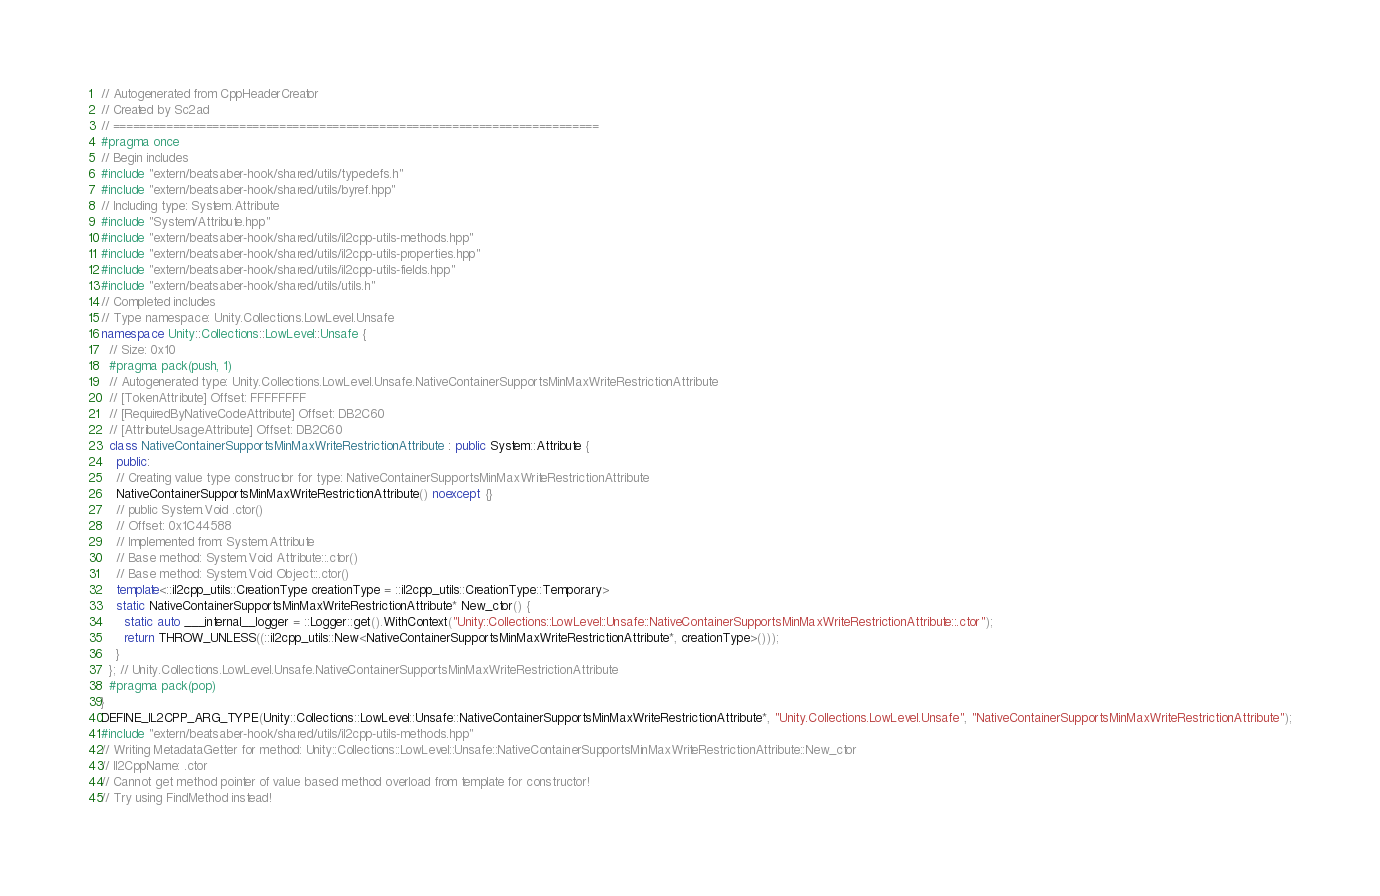Convert code to text. <code><loc_0><loc_0><loc_500><loc_500><_C++_>// Autogenerated from CppHeaderCreator
// Created by Sc2ad
// =========================================================================
#pragma once
// Begin includes
#include "extern/beatsaber-hook/shared/utils/typedefs.h"
#include "extern/beatsaber-hook/shared/utils/byref.hpp"
// Including type: System.Attribute
#include "System/Attribute.hpp"
#include "extern/beatsaber-hook/shared/utils/il2cpp-utils-methods.hpp"
#include "extern/beatsaber-hook/shared/utils/il2cpp-utils-properties.hpp"
#include "extern/beatsaber-hook/shared/utils/il2cpp-utils-fields.hpp"
#include "extern/beatsaber-hook/shared/utils/utils.h"
// Completed includes
// Type namespace: Unity.Collections.LowLevel.Unsafe
namespace Unity::Collections::LowLevel::Unsafe {
  // Size: 0x10
  #pragma pack(push, 1)
  // Autogenerated type: Unity.Collections.LowLevel.Unsafe.NativeContainerSupportsMinMaxWriteRestrictionAttribute
  // [TokenAttribute] Offset: FFFFFFFF
  // [RequiredByNativeCodeAttribute] Offset: DB2C60
  // [AttributeUsageAttribute] Offset: DB2C60
  class NativeContainerSupportsMinMaxWriteRestrictionAttribute : public System::Attribute {
    public:
    // Creating value type constructor for type: NativeContainerSupportsMinMaxWriteRestrictionAttribute
    NativeContainerSupportsMinMaxWriteRestrictionAttribute() noexcept {}
    // public System.Void .ctor()
    // Offset: 0x1C44588
    // Implemented from: System.Attribute
    // Base method: System.Void Attribute::.ctor()
    // Base method: System.Void Object::.ctor()
    template<::il2cpp_utils::CreationType creationType = ::il2cpp_utils::CreationType::Temporary>
    static NativeContainerSupportsMinMaxWriteRestrictionAttribute* New_ctor() {
      static auto ___internal__logger = ::Logger::get().WithContext("Unity::Collections::LowLevel::Unsafe::NativeContainerSupportsMinMaxWriteRestrictionAttribute::.ctor");
      return THROW_UNLESS((::il2cpp_utils::New<NativeContainerSupportsMinMaxWriteRestrictionAttribute*, creationType>()));
    }
  }; // Unity.Collections.LowLevel.Unsafe.NativeContainerSupportsMinMaxWriteRestrictionAttribute
  #pragma pack(pop)
}
DEFINE_IL2CPP_ARG_TYPE(Unity::Collections::LowLevel::Unsafe::NativeContainerSupportsMinMaxWriteRestrictionAttribute*, "Unity.Collections.LowLevel.Unsafe", "NativeContainerSupportsMinMaxWriteRestrictionAttribute");
#include "extern/beatsaber-hook/shared/utils/il2cpp-utils-methods.hpp"
// Writing MetadataGetter for method: Unity::Collections::LowLevel::Unsafe::NativeContainerSupportsMinMaxWriteRestrictionAttribute::New_ctor
// Il2CppName: .ctor
// Cannot get method pointer of value based method overload from template for constructor!
// Try using FindMethod instead!
</code> 